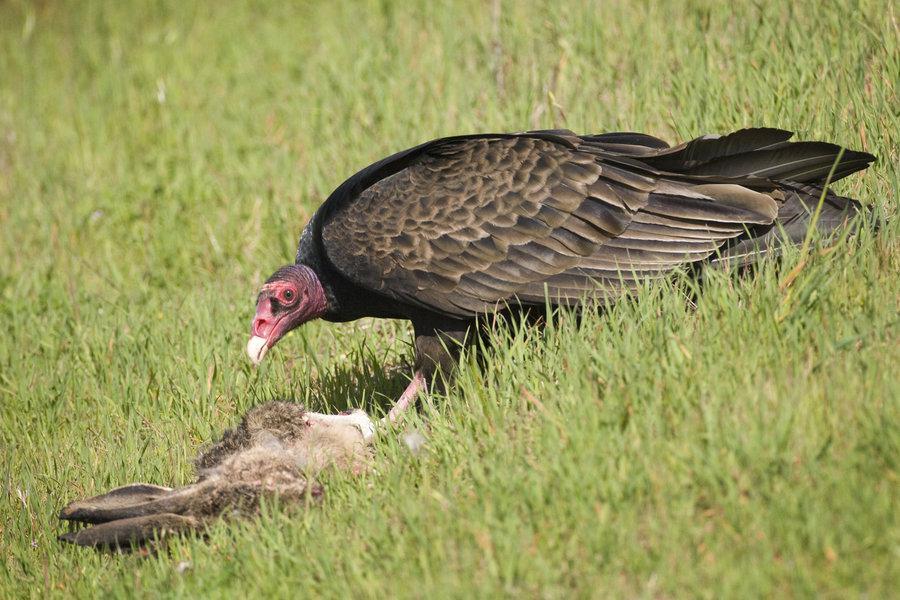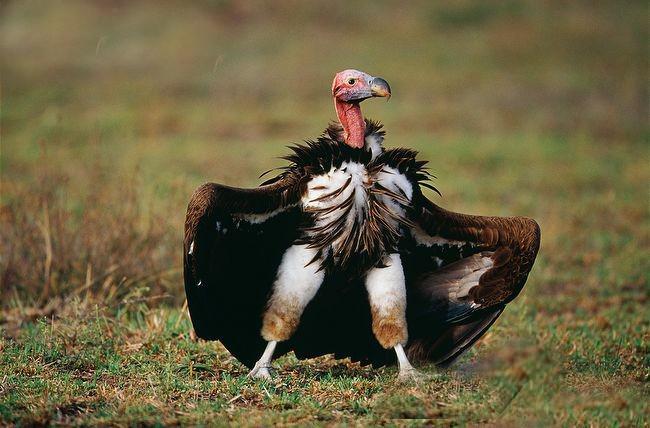The first image is the image on the left, the second image is the image on the right. Examine the images to the left and right. Is the description "An image shows multiple brown vultures around a ribcage." accurate? Answer yes or no. No. 